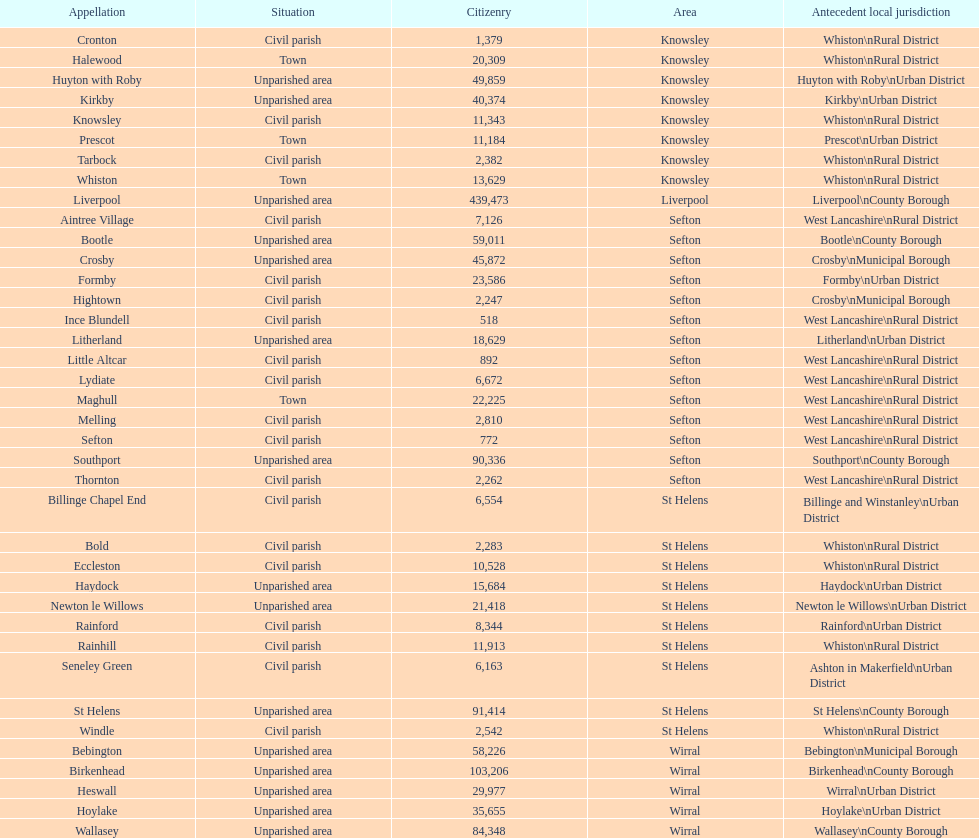Is a civil parish found in aintree village or maghull? Aintree Village. 